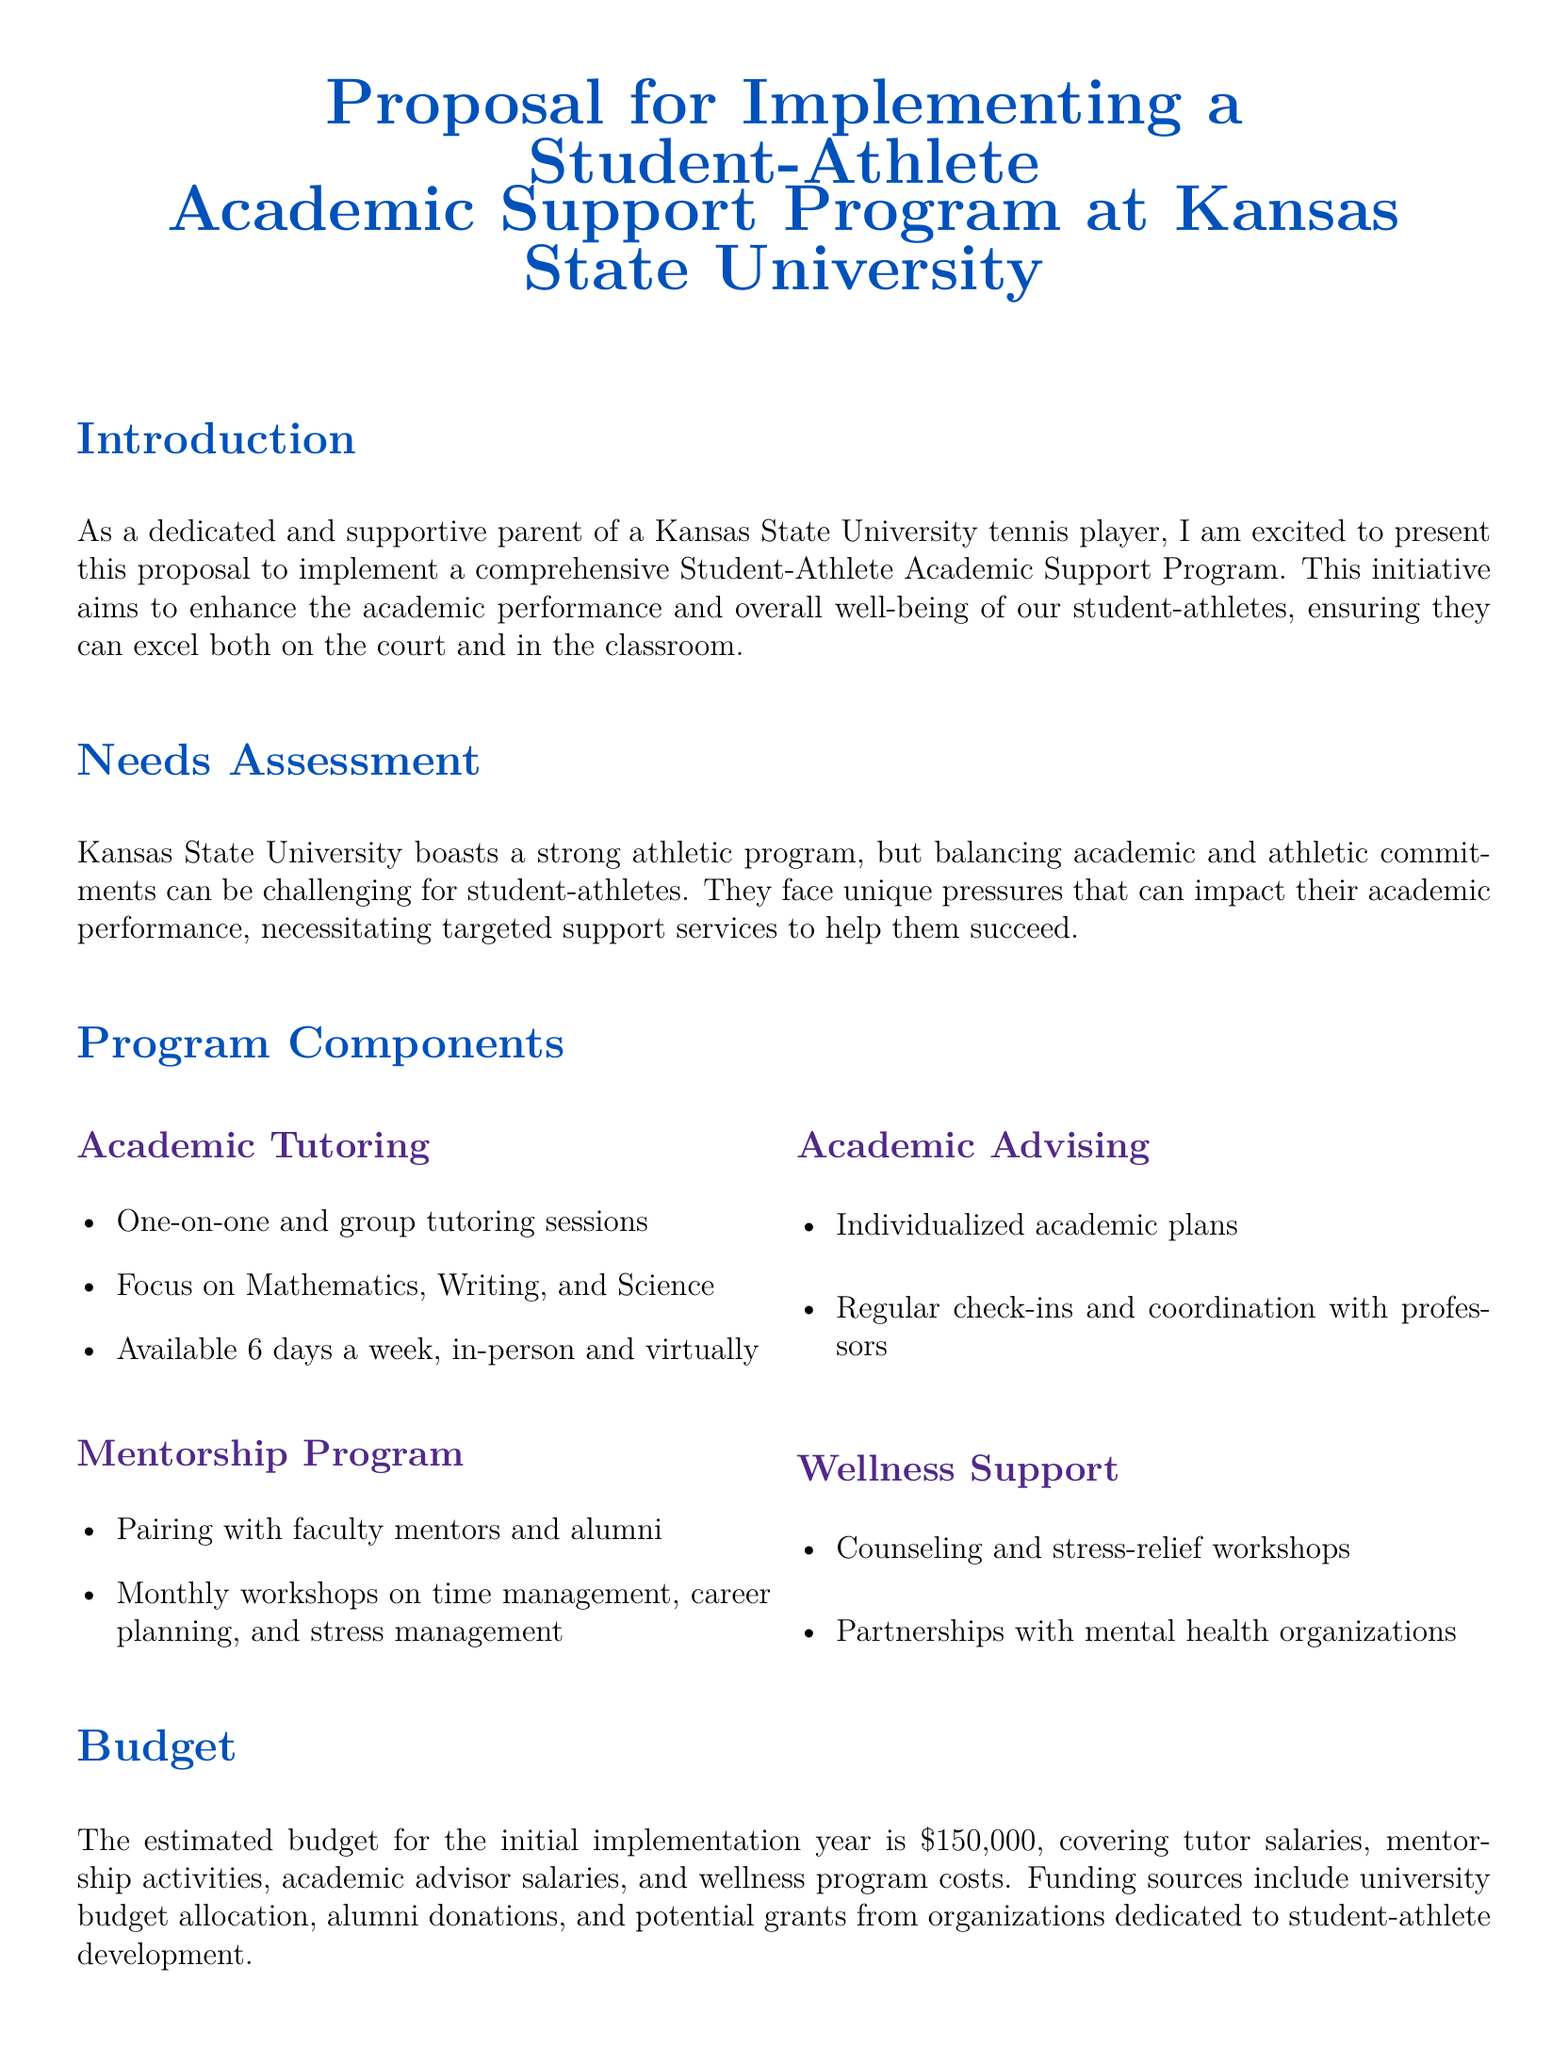What is the main goal of the proposal? The proposal aims to enhance the academic performance and overall well-being of student-athletes at Kansas State University.
Answer: Enhance academic performance What are the specific academic subjects mentioned for tutoring? The subjects focused on in the tutoring sessions include Mathematics, Writing, and Science.
Answer: Mathematics, Writing, Science How much is the estimated budget for the initial implementation year? The estimated budget for the program's initial implementation year is specified in the document.
Answer: $150,000 What kind of support does the mentorship program offer? The mentorship program pairs student-athletes with faculty mentors and alumni, providing workshops on various skills.
Answer: Faculty mentors and alumni How often are tutoring sessions available? The document specifies the availability of tutoring sessions as 6 days a week.
Answer: 6 days a week What will be measured to gauge the program's success? The proposal outlines that success will be measured through GPA tracking, graduation rates, and feedback from student-athletes.
Answer: GPA tracking, graduation rates, and feedback What type of workshops are included under wellness support? The wellness support section includes counseling and stress-relief workshops.
Answer: Counseling and stress-relief workshops Who will provide funding for the program? Funding sources mentioned in the proposal include university budget allocation, alumni donations, and potential grants.
Answer: University budget allocation, alumni donations, grants What is included in the individualized academic plans? The individualized academic plans include regular check-ins and coordination with professors.
Answer: Regular check-ins and coordination with professors 